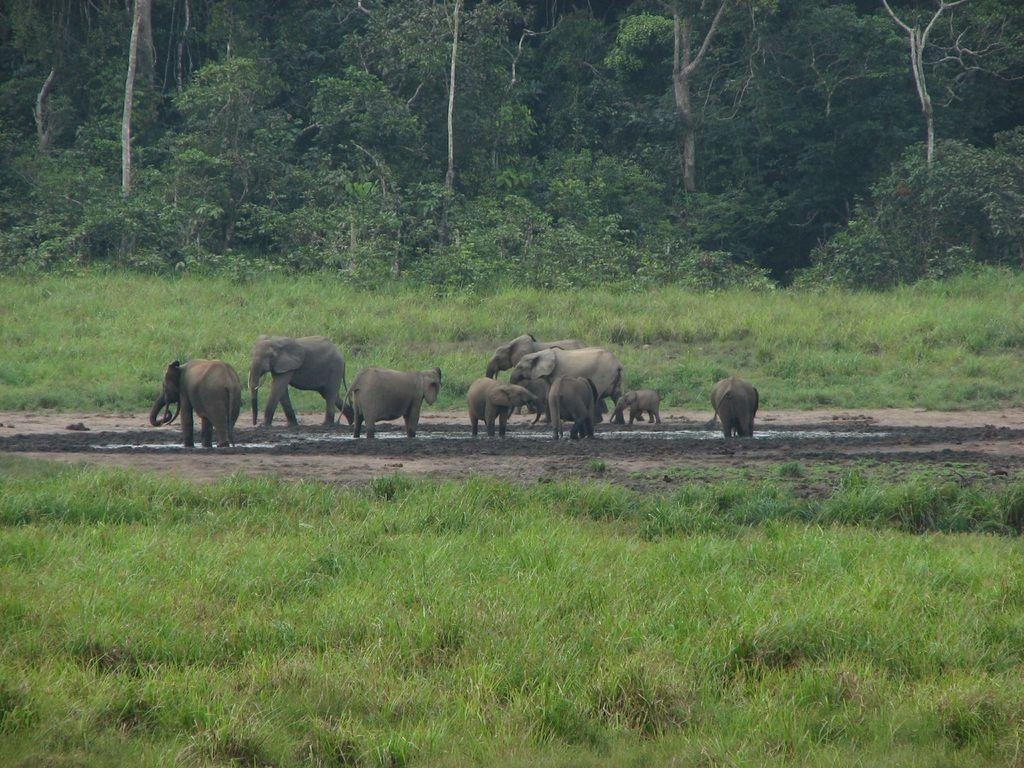What animals can be seen in the image? There are elephants in the image. What are the elephants doing in the image? The elephants are standing and walking on the land. What type of vegetation is present on either side of the land? There is grass on either side of the land. What can be seen in the background of the image? There are trees in the background of the image. What type of cloth is being used to sort the elephants in the image? There is no cloth or sorting activity present in the image; it features elephants standing and walking on the land. Can you tell me the name of the mom elephant in the image? There is no indication of a mom elephant or any specific elephants in the image, as it simply shows multiple elephants standing and walking on the land. 